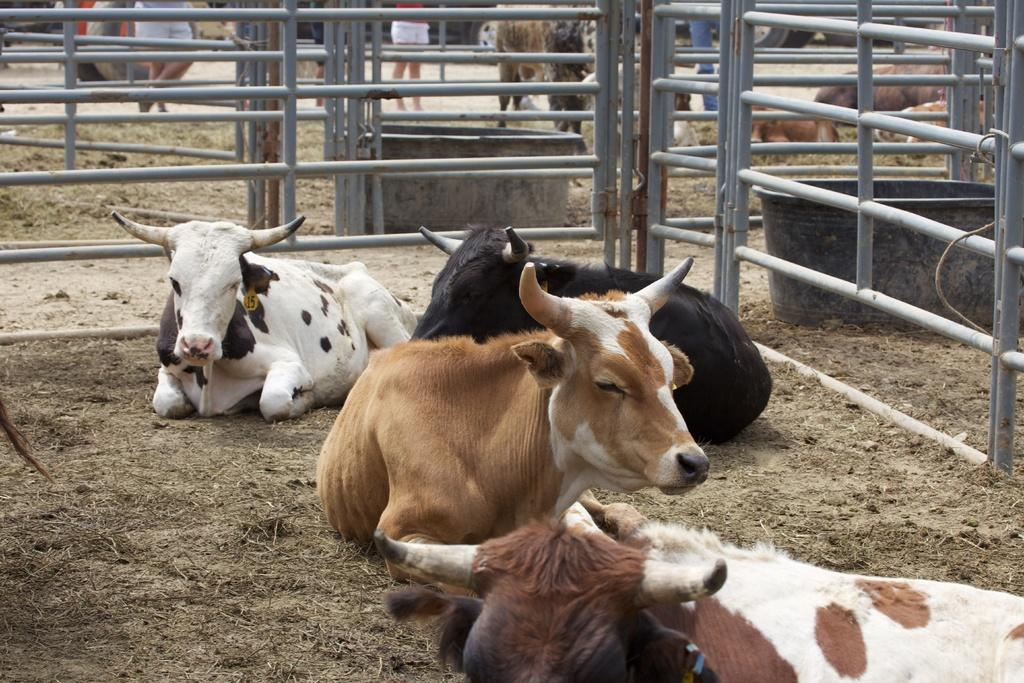What animals can be seen on the ground in the image? There are cows on the ground in the image. What structures are present in the image? There are railings and water troughs in the image. What can be seen in the background of the image? There are people and additional cows visible in the background of the image. What type of oatmeal is being served to the cows in the image? There is no oatmeal present in the image; the cows are near water troughs. On which side of the image are the cows located? The question about the side of the image is irrelevant, as the cows are visible throughout the image. 